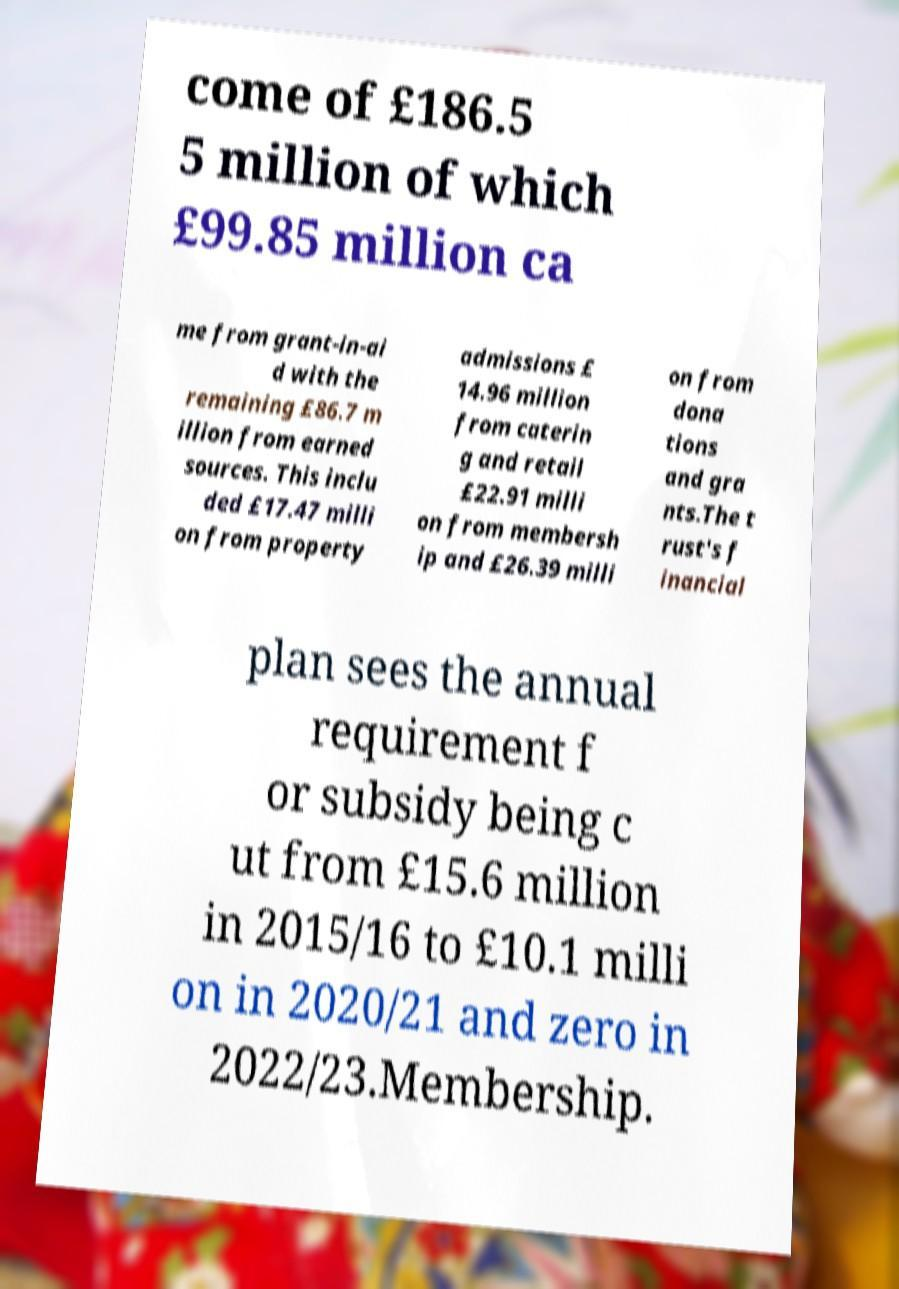Could you extract and type out the text from this image? come of £186.5 5 million of which £99.85 million ca me from grant-in-ai d with the remaining £86.7 m illion from earned sources. This inclu ded £17.47 milli on from property admissions £ 14.96 million from caterin g and retail £22.91 milli on from membersh ip and £26.39 milli on from dona tions and gra nts.The t rust's f inancial plan sees the annual requirement f or subsidy being c ut from £15.6 million in 2015/16 to £10.1 milli on in 2020/21 and zero in 2022/23.Membership. 